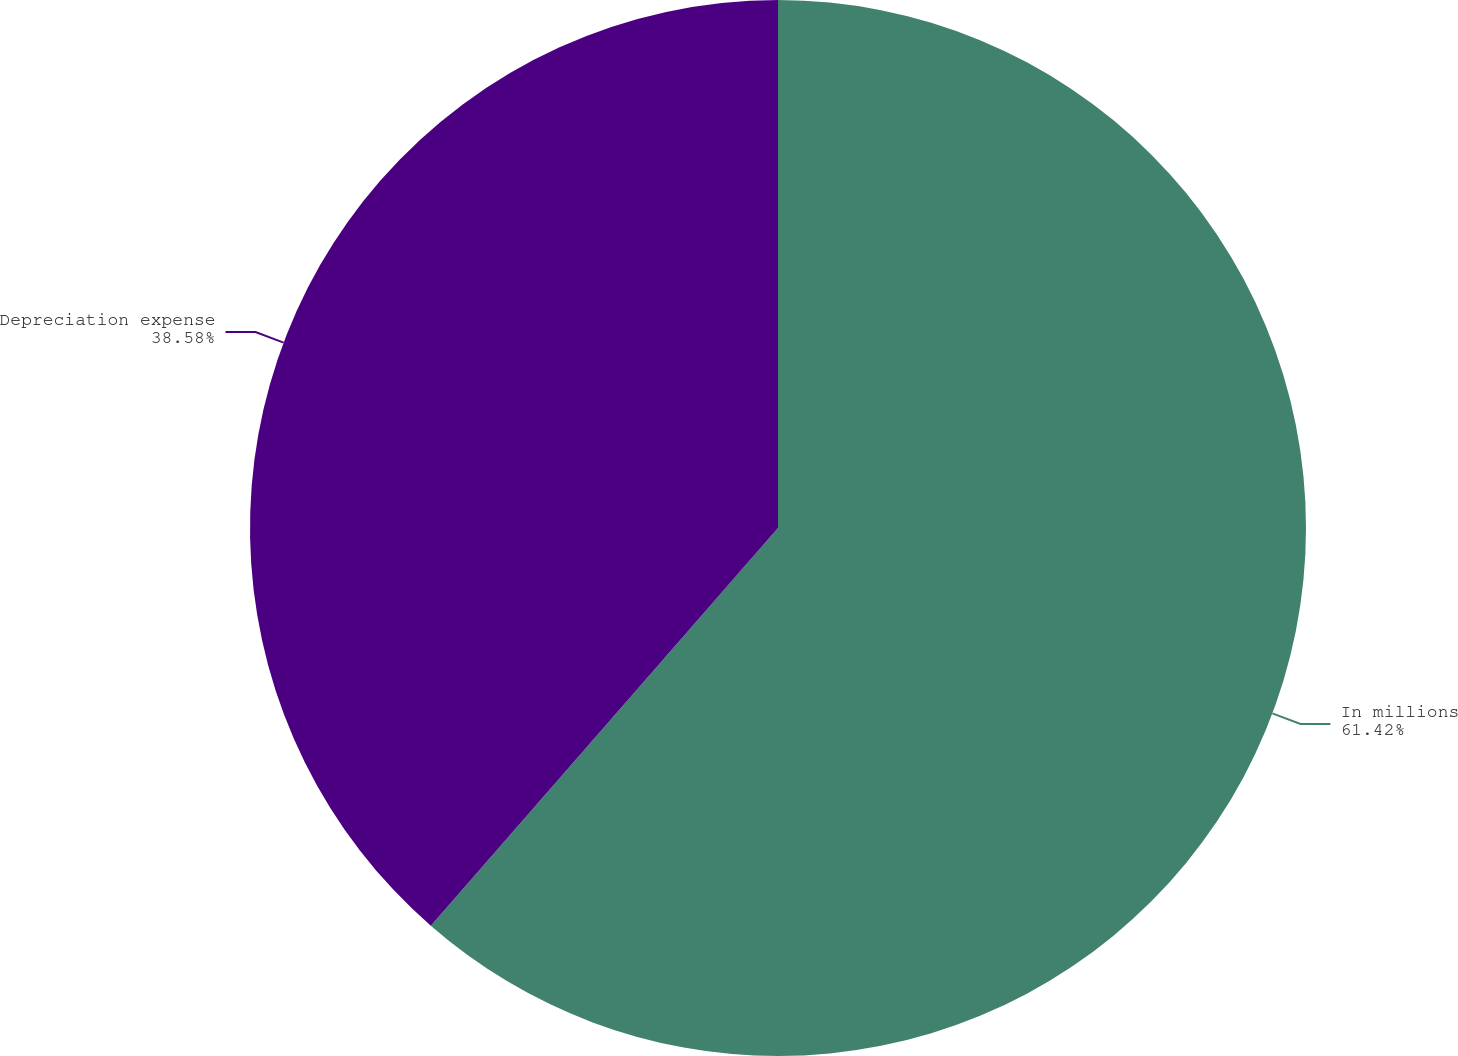<chart> <loc_0><loc_0><loc_500><loc_500><pie_chart><fcel>In millions<fcel>Depreciation expense<nl><fcel>61.42%<fcel>38.58%<nl></chart> 